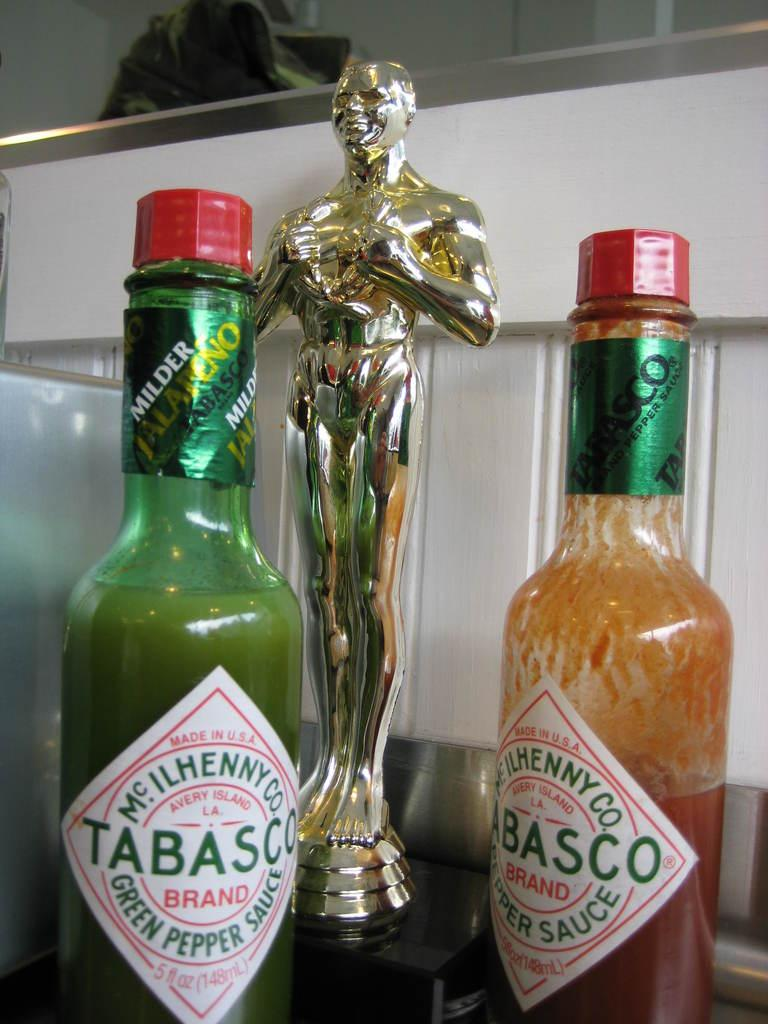<image>
Relay a brief, clear account of the picture shown. Two bottles of Tabasco sauce, one red, one green, on either side of a trophy. 